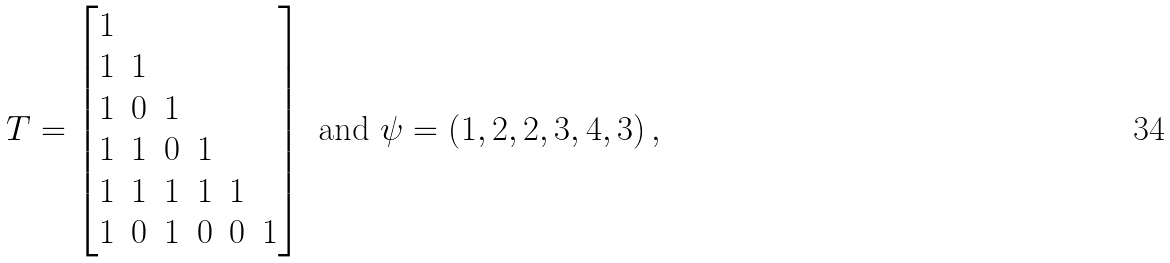Convert formula to latex. <formula><loc_0><loc_0><loc_500><loc_500>T = \begin{bmatrix} 1 \\ 1 & 1 \\ 1 & 0 & 1 \\ 1 & 1 & 0 & 1 \\ 1 & 1 & 1 & 1 & 1 \\ 1 & 0 & 1 & 0 & 0 & 1 \\ \end{bmatrix} \text { and } \psi = \left ( 1 , 2 , 2 , 3 , 4 , 3 \right ) ,</formula> 